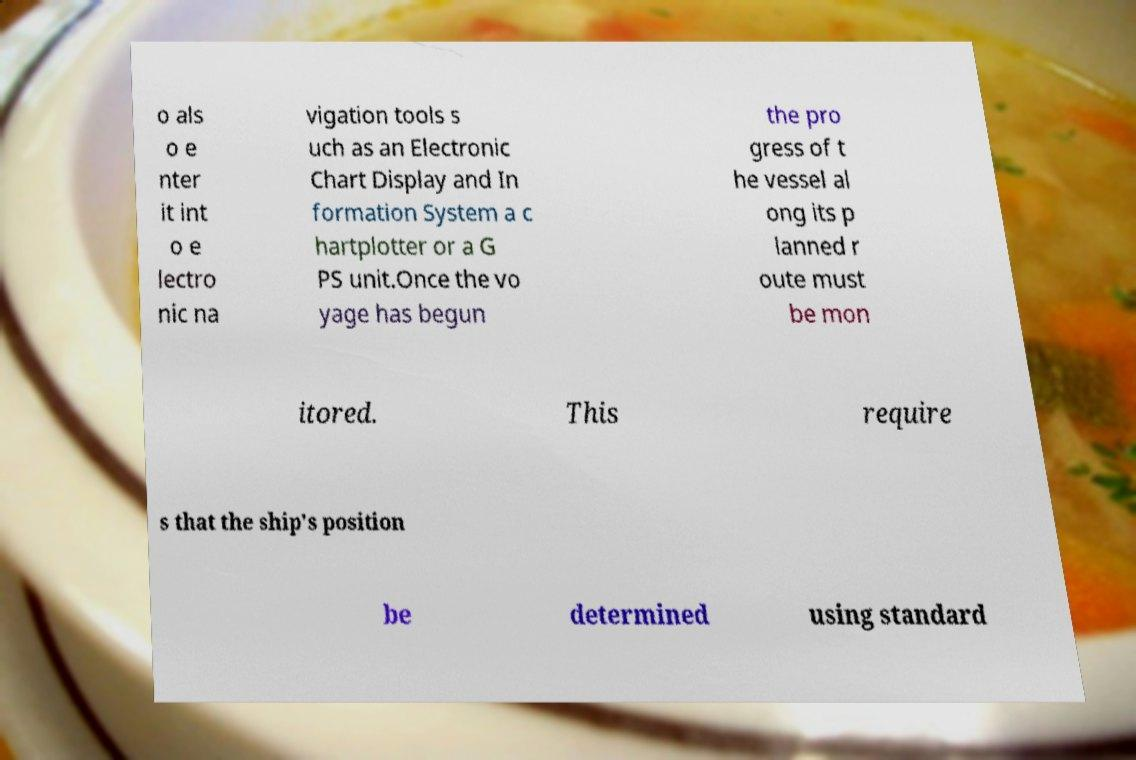There's text embedded in this image that I need extracted. Can you transcribe it verbatim? o als o e nter it int o e lectro nic na vigation tools s uch as an Electronic Chart Display and In formation System a c hartplotter or a G PS unit.Once the vo yage has begun the pro gress of t he vessel al ong its p lanned r oute must be mon itored. This require s that the ship's position be determined using standard 